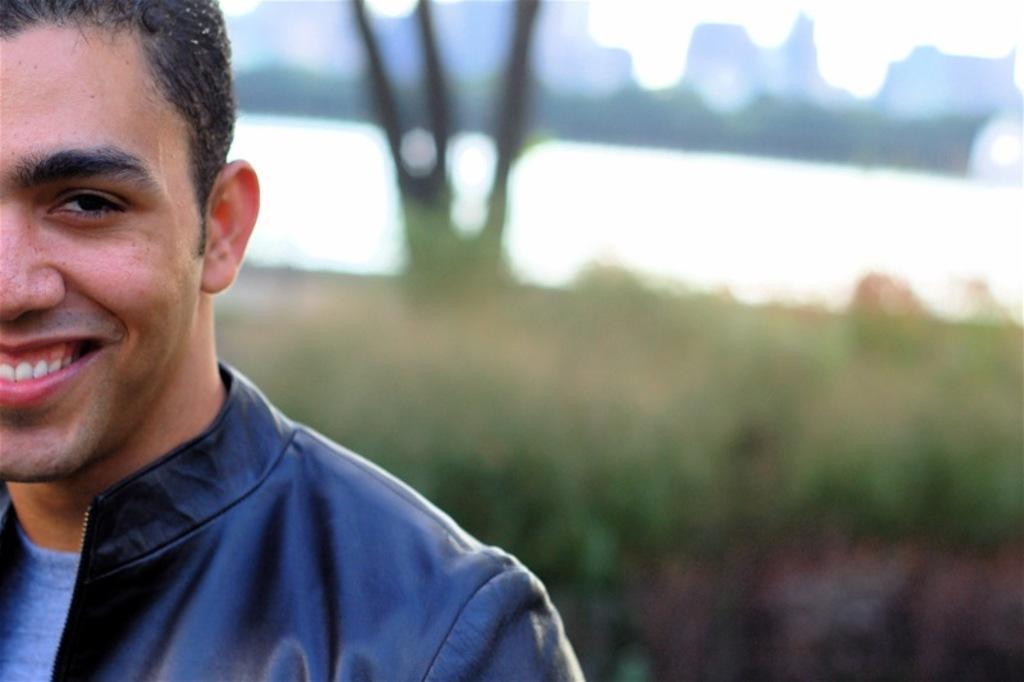Can you describe this image briefly? Background portion of the picture is blur. Here we can see a man wearing a black jacket and he is smiling. 